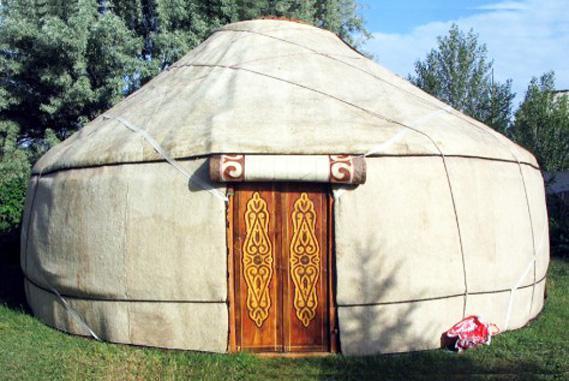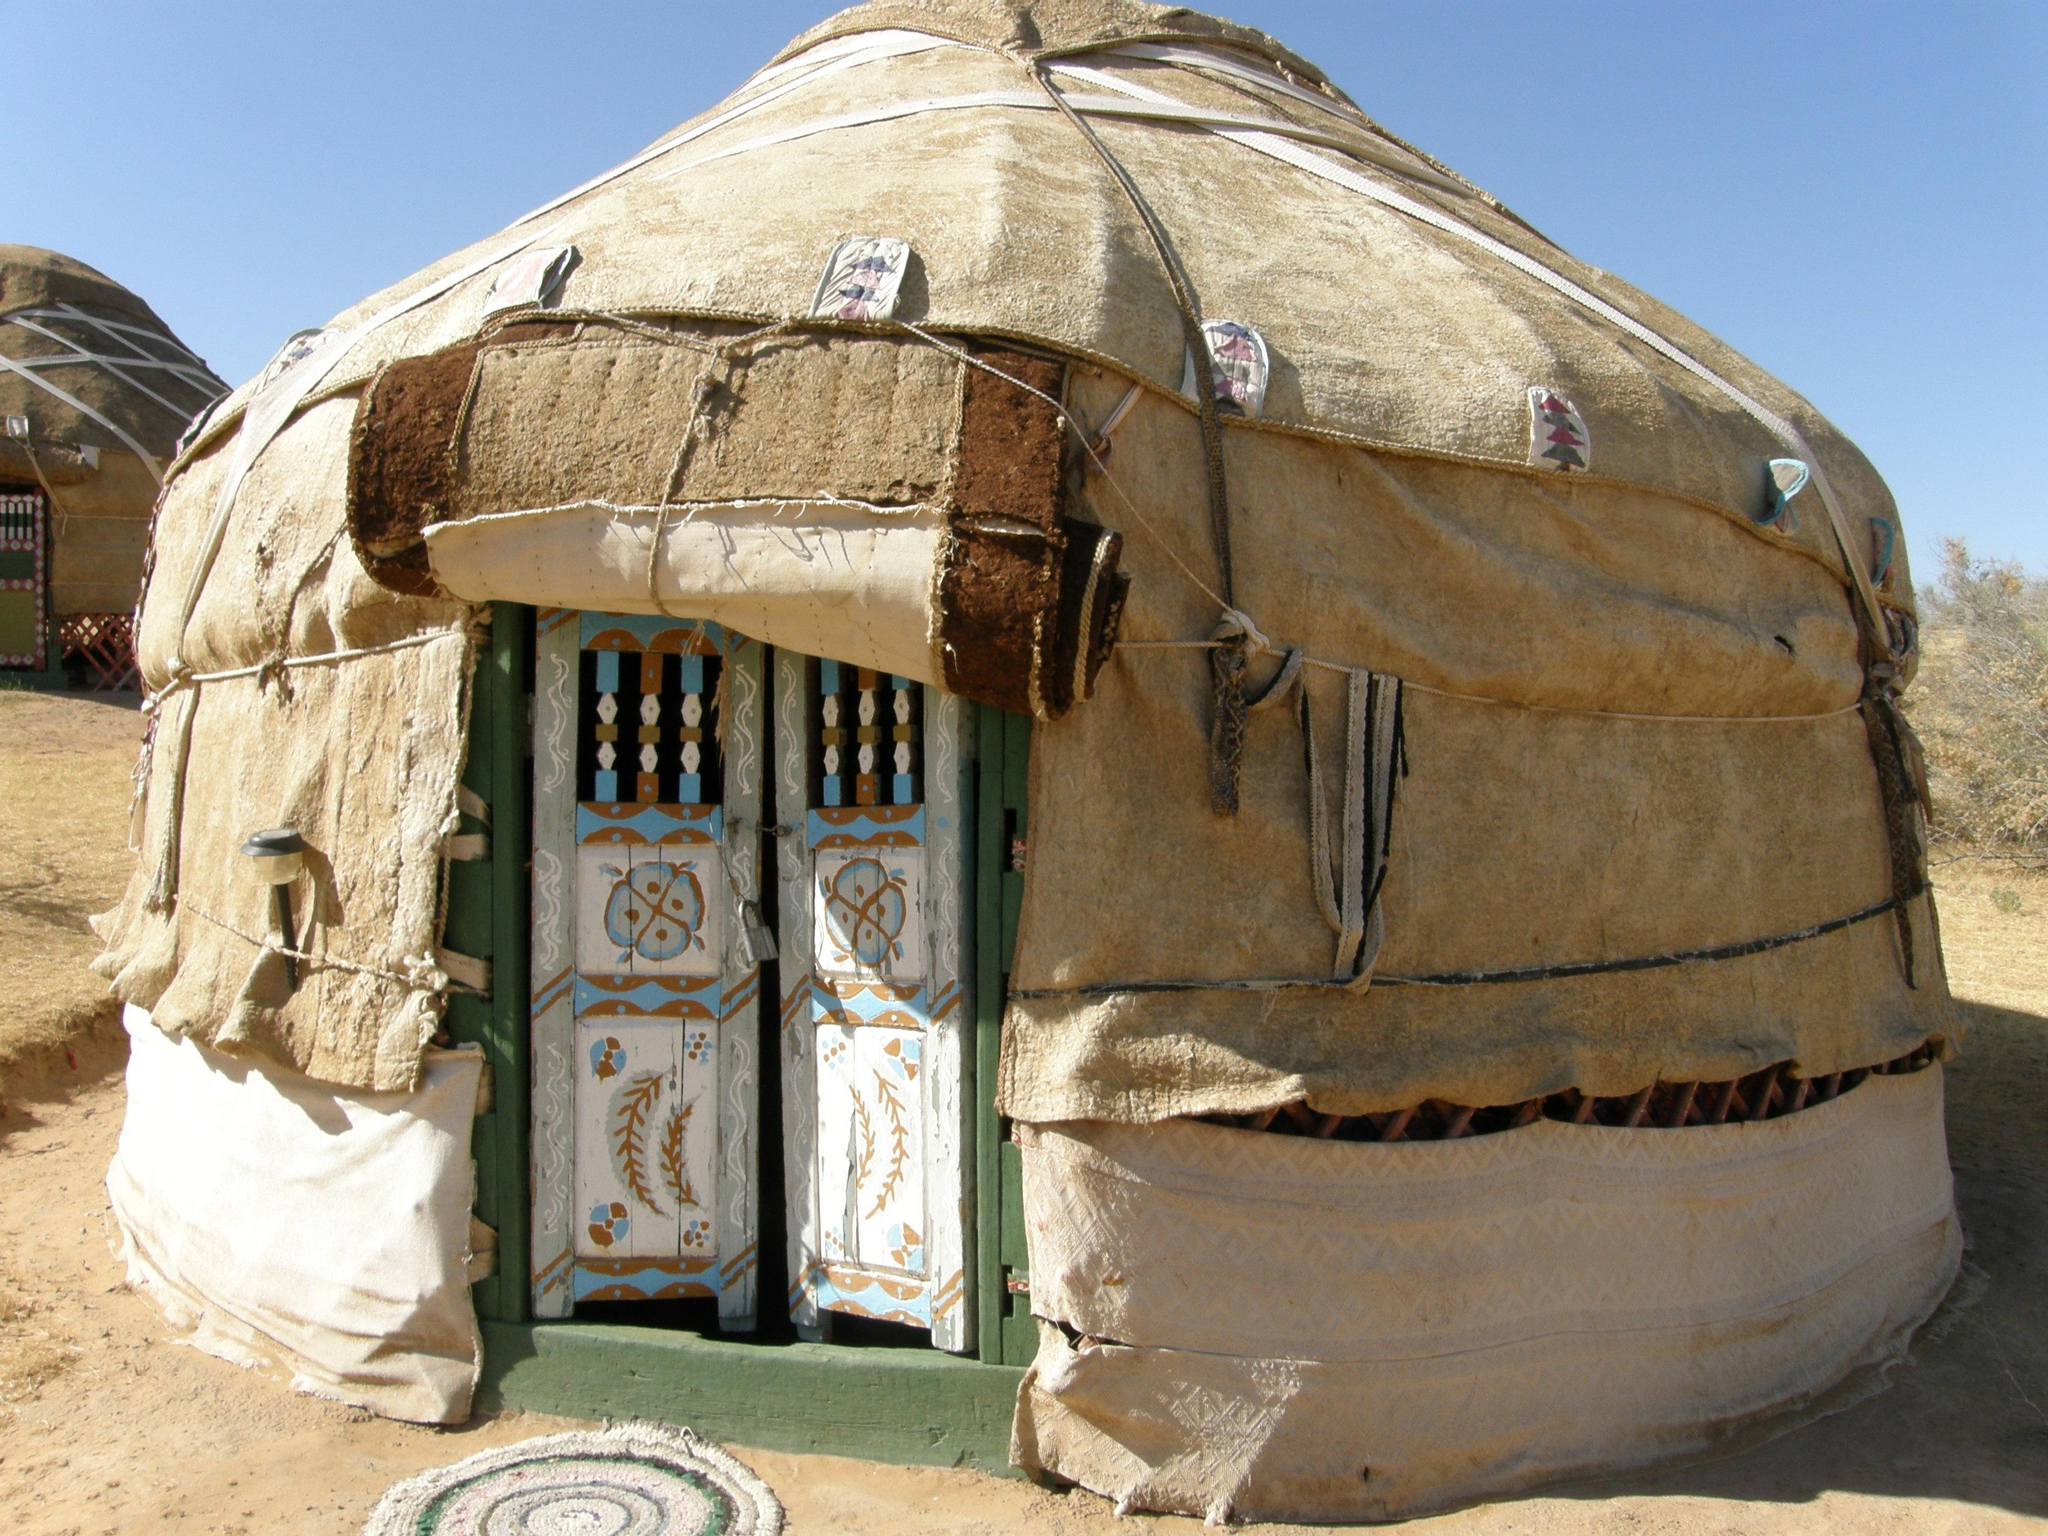The first image is the image on the left, the second image is the image on the right. For the images shown, is this caption "There are 4 or more people next to tents." true? Answer yes or no. No. The first image is the image on the left, the second image is the image on the right. For the images displayed, is the sentence "The building has a wooden ornamental door" factually correct? Answer yes or no. Yes. 